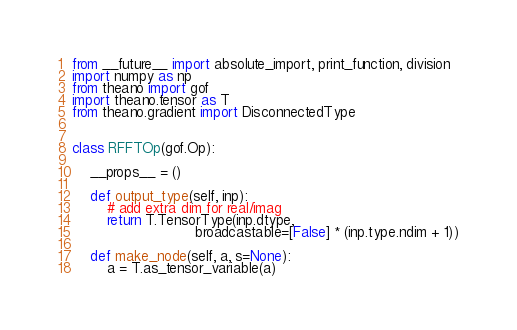<code> <loc_0><loc_0><loc_500><loc_500><_Python_>from __future__ import absolute_import, print_function, division
import numpy as np
from theano import gof
import theano.tensor as T
from theano.gradient import DisconnectedType


class RFFTOp(gof.Op):

    __props__ = ()

    def output_type(self, inp):
        # add extra dim for real/imag
        return T.TensorType(inp.dtype,
                            broadcastable=[False] * (inp.type.ndim + 1))

    def make_node(self, a, s=None):
        a = T.as_tensor_variable(a)</code> 